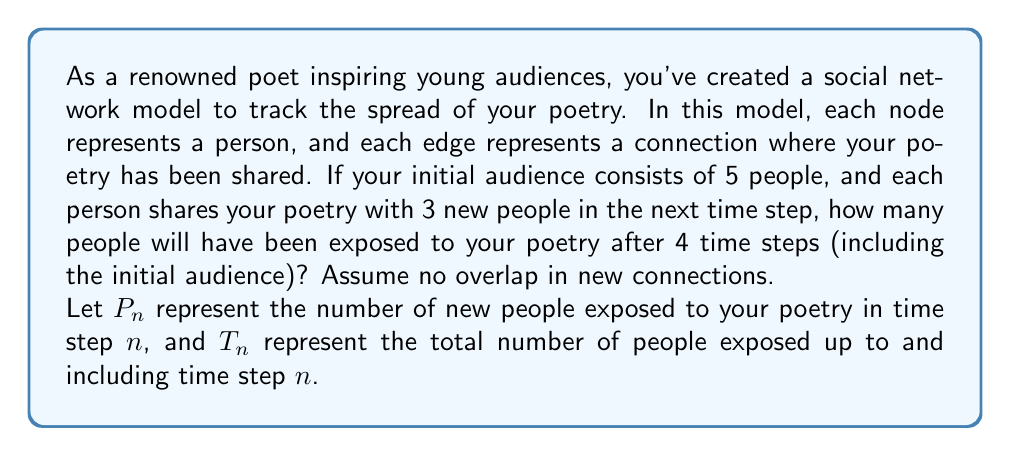Can you solve this math problem? To solve this problem, we'll use concepts from graph theory and geometric series. Let's break it down step-by-step:

1) Initial conditions:
   $P_0 = 5$ (initial audience)
   $T_0 = 5$ (total after 0 time steps)

2) For each subsequent time step:
   $P_n = 3P_{n-1}$ (each person shares with 3 new people)

3) We can express $P_n$ in terms of $P_0$:
   $P_1 = 3P_0 = 3 \cdot 5 = 15$
   $P_2 = 3P_1 = 3 \cdot 15 = 45$
   $P_3 = 3P_2 = 3 \cdot 45 = 135$
   $P_4 = 3P_3 = 3 \cdot 135 = 405$

4) In general, $P_n = 5 \cdot 3^n$ for $n > 0$

5) The total number of people exposed after $n$ time steps is the sum of all new people in each step plus the initial audience:

   $T_n = P_0 + P_1 + P_2 + ... + P_n$

6) This forms a geometric series with first term $a = 5$ and common ratio $r = 3$:

   $T_n = 5 + 5 \cdot 3 + 5 \cdot 3^2 + ... + 5 \cdot 3^n$

7) The sum of a geometric series is given by the formula:

   $S_n = a\frac{1-r^{n+1}}{1-r}$ where $a$ is the first term and $r$ is the common ratio

8) Applying this formula to our series:

   $T_n = 5\frac{1-3^{n+1}}{1-3} = \frac{5(3^{n+1}-1)}{2}$

9) For $n = 4$ (4 time steps):

   $T_4 = \frac{5(3^5-1)}{2} = \frac{5(243-1)}{2} = \frac{5 \cdot 242}{2} = 605$

Therefore, after 4 time steps, 605 people will have been exposed to your poetry.
Answer: 605 people 